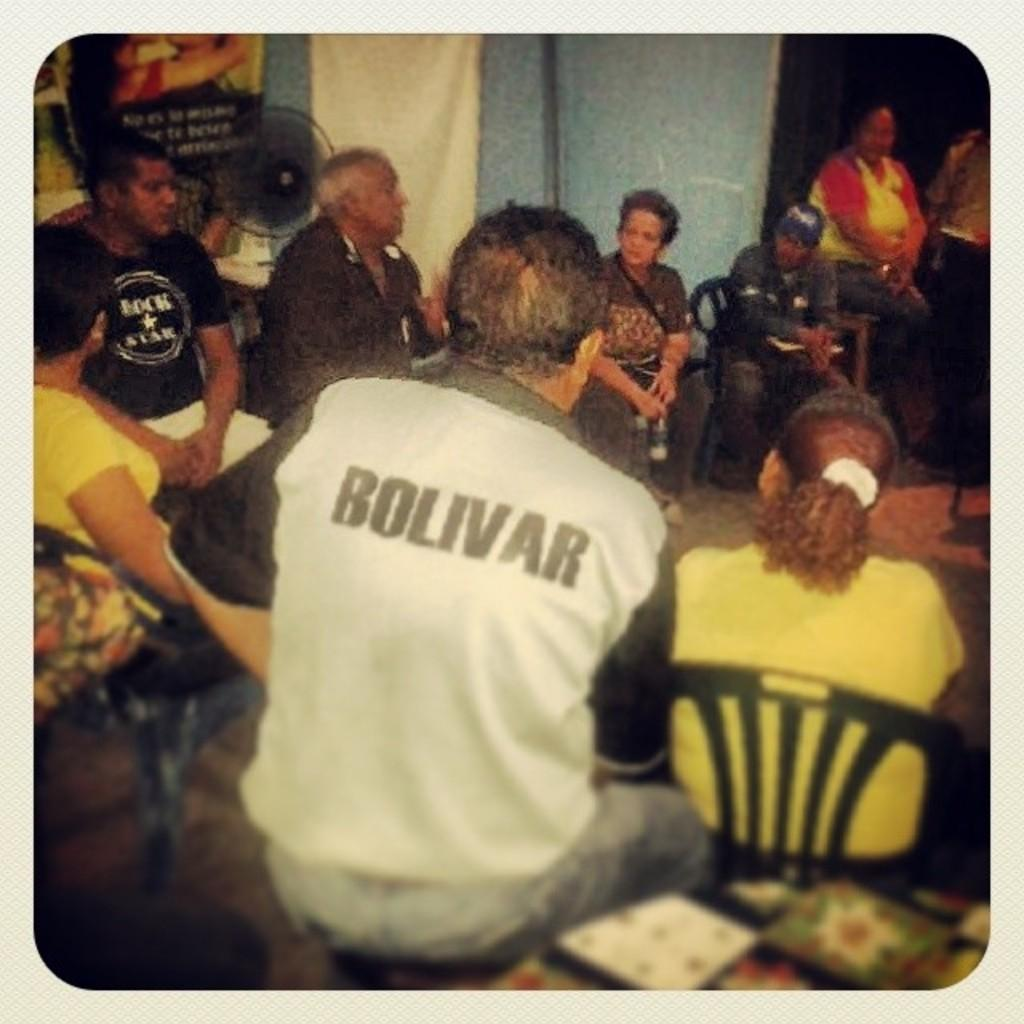What is happening in the image involving the group of people? The group of men and women in the image are engaged in a discussion. Where is the group of people located in the image? The group is sitting in a hall. What can be seen in the image that provides ventilation or cooling? There is a black color table fan in the image. What type of window treatment is present in the image? There is a blue color curtain in the image. How many arms are visible on the marble statue in the image? There is no marble statue present in the image, so it is not possible to determine the number of arms visible. 